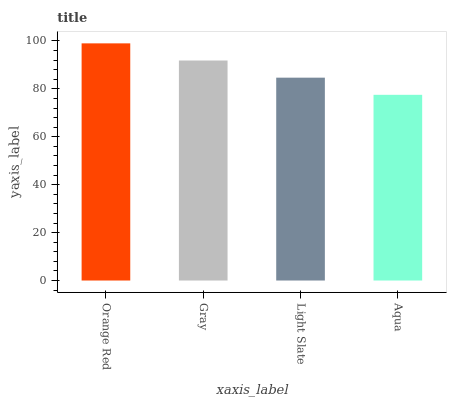Is Aqua the minimum?
Answer yes or no. Yes. Is Orange Red the maximum?
Answer yes or no. Yes. Is Gray the minimum?
Answer yes or no. No. Is Gray the maximum?
Answer yes or no. No. Is Orange Red greater than Gray?
Answer yes or no. Yes. Is Gray less than Orange Red?
Answer yes or no. Yes. Is Gray greater than Orange Red?
Answer yes or no. No. Is Orange Red less than Gray?
Answer yes or no. No. Is Gray the high median?
Answer yes or no. Yes. Is Light Slate the low median?
Answer yes or no. Yes. Is Orange Red the high median?
Answer yes or no. No. Is Orange Red the low median?
Answer yes or no. No. 